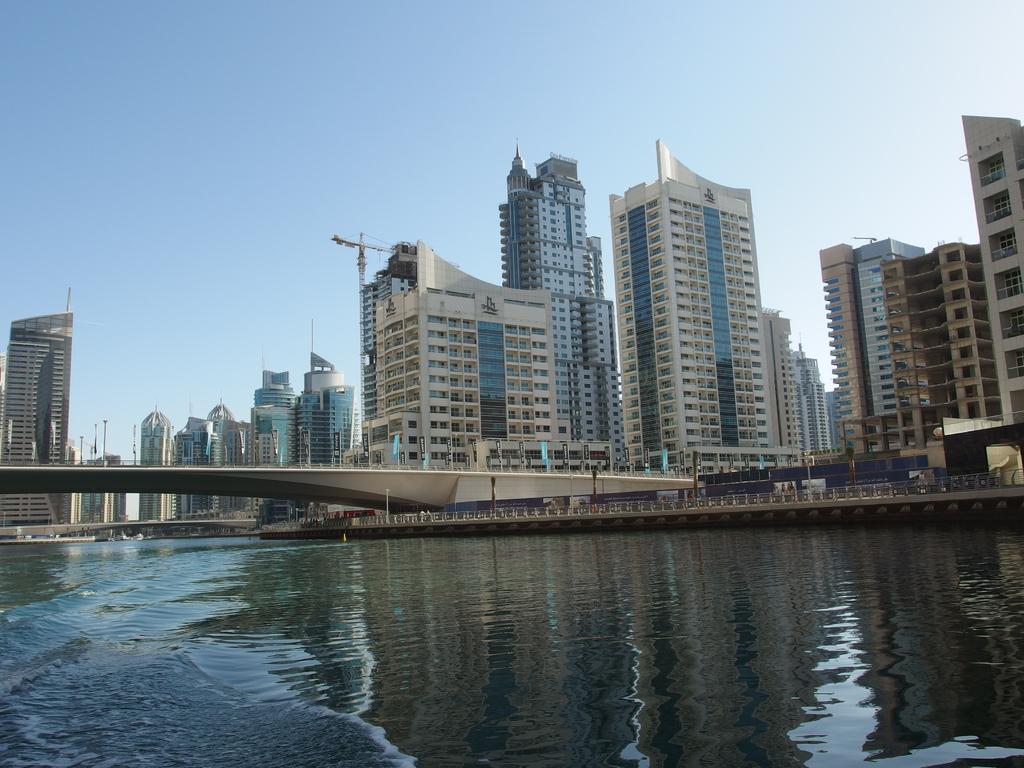Please provide a concise description of this image. Here in this picture we can see buildings present all over there and in the front we can see water present all over there and in the middle we can see a bridge present over there. 